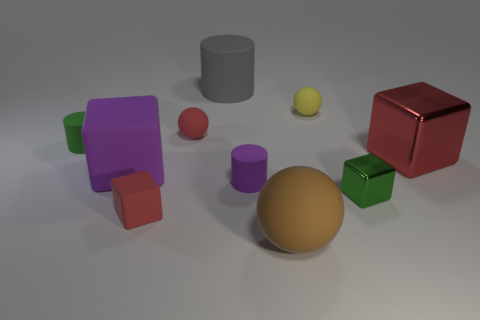Subtract all blocks. How many objects are left? 6 Add 5 purple matte cylinders. How many purple matte cylinders are left? 6 Add 1 yellow matte things. How many yellow matte things exist? 2 Subtract 0 green spheres. How many objects are left? 10 Subtract all red balls. Subtract all big balls. How many objects are left? 8 